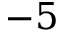<formula> <loc_0><loc_0><loc_500><loc_500>- 5</formula> 